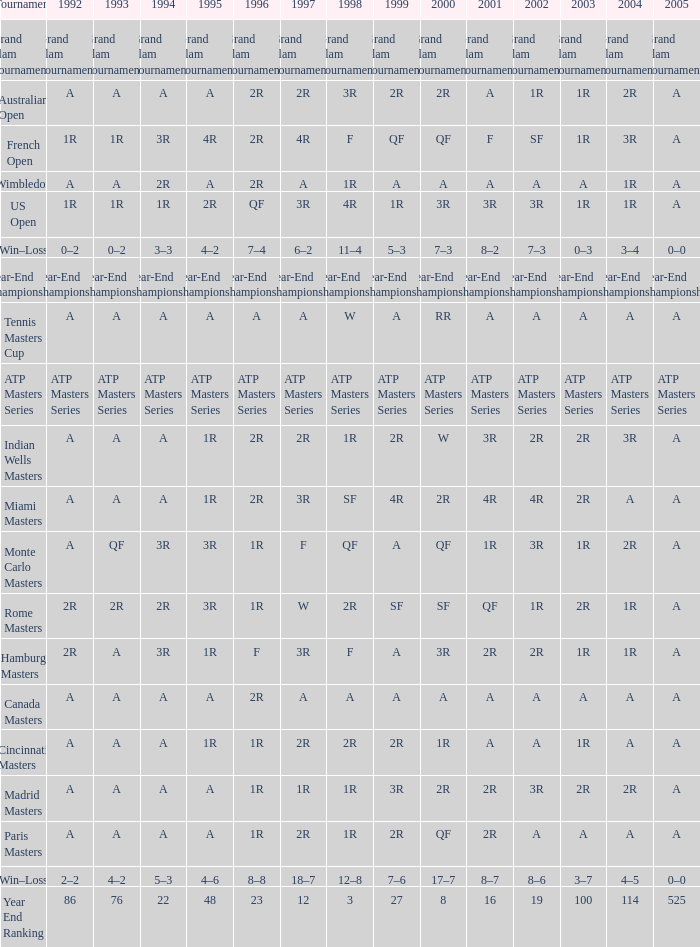What is 1992, when 1999 is "final championship of the year"? Year-End Championship. 